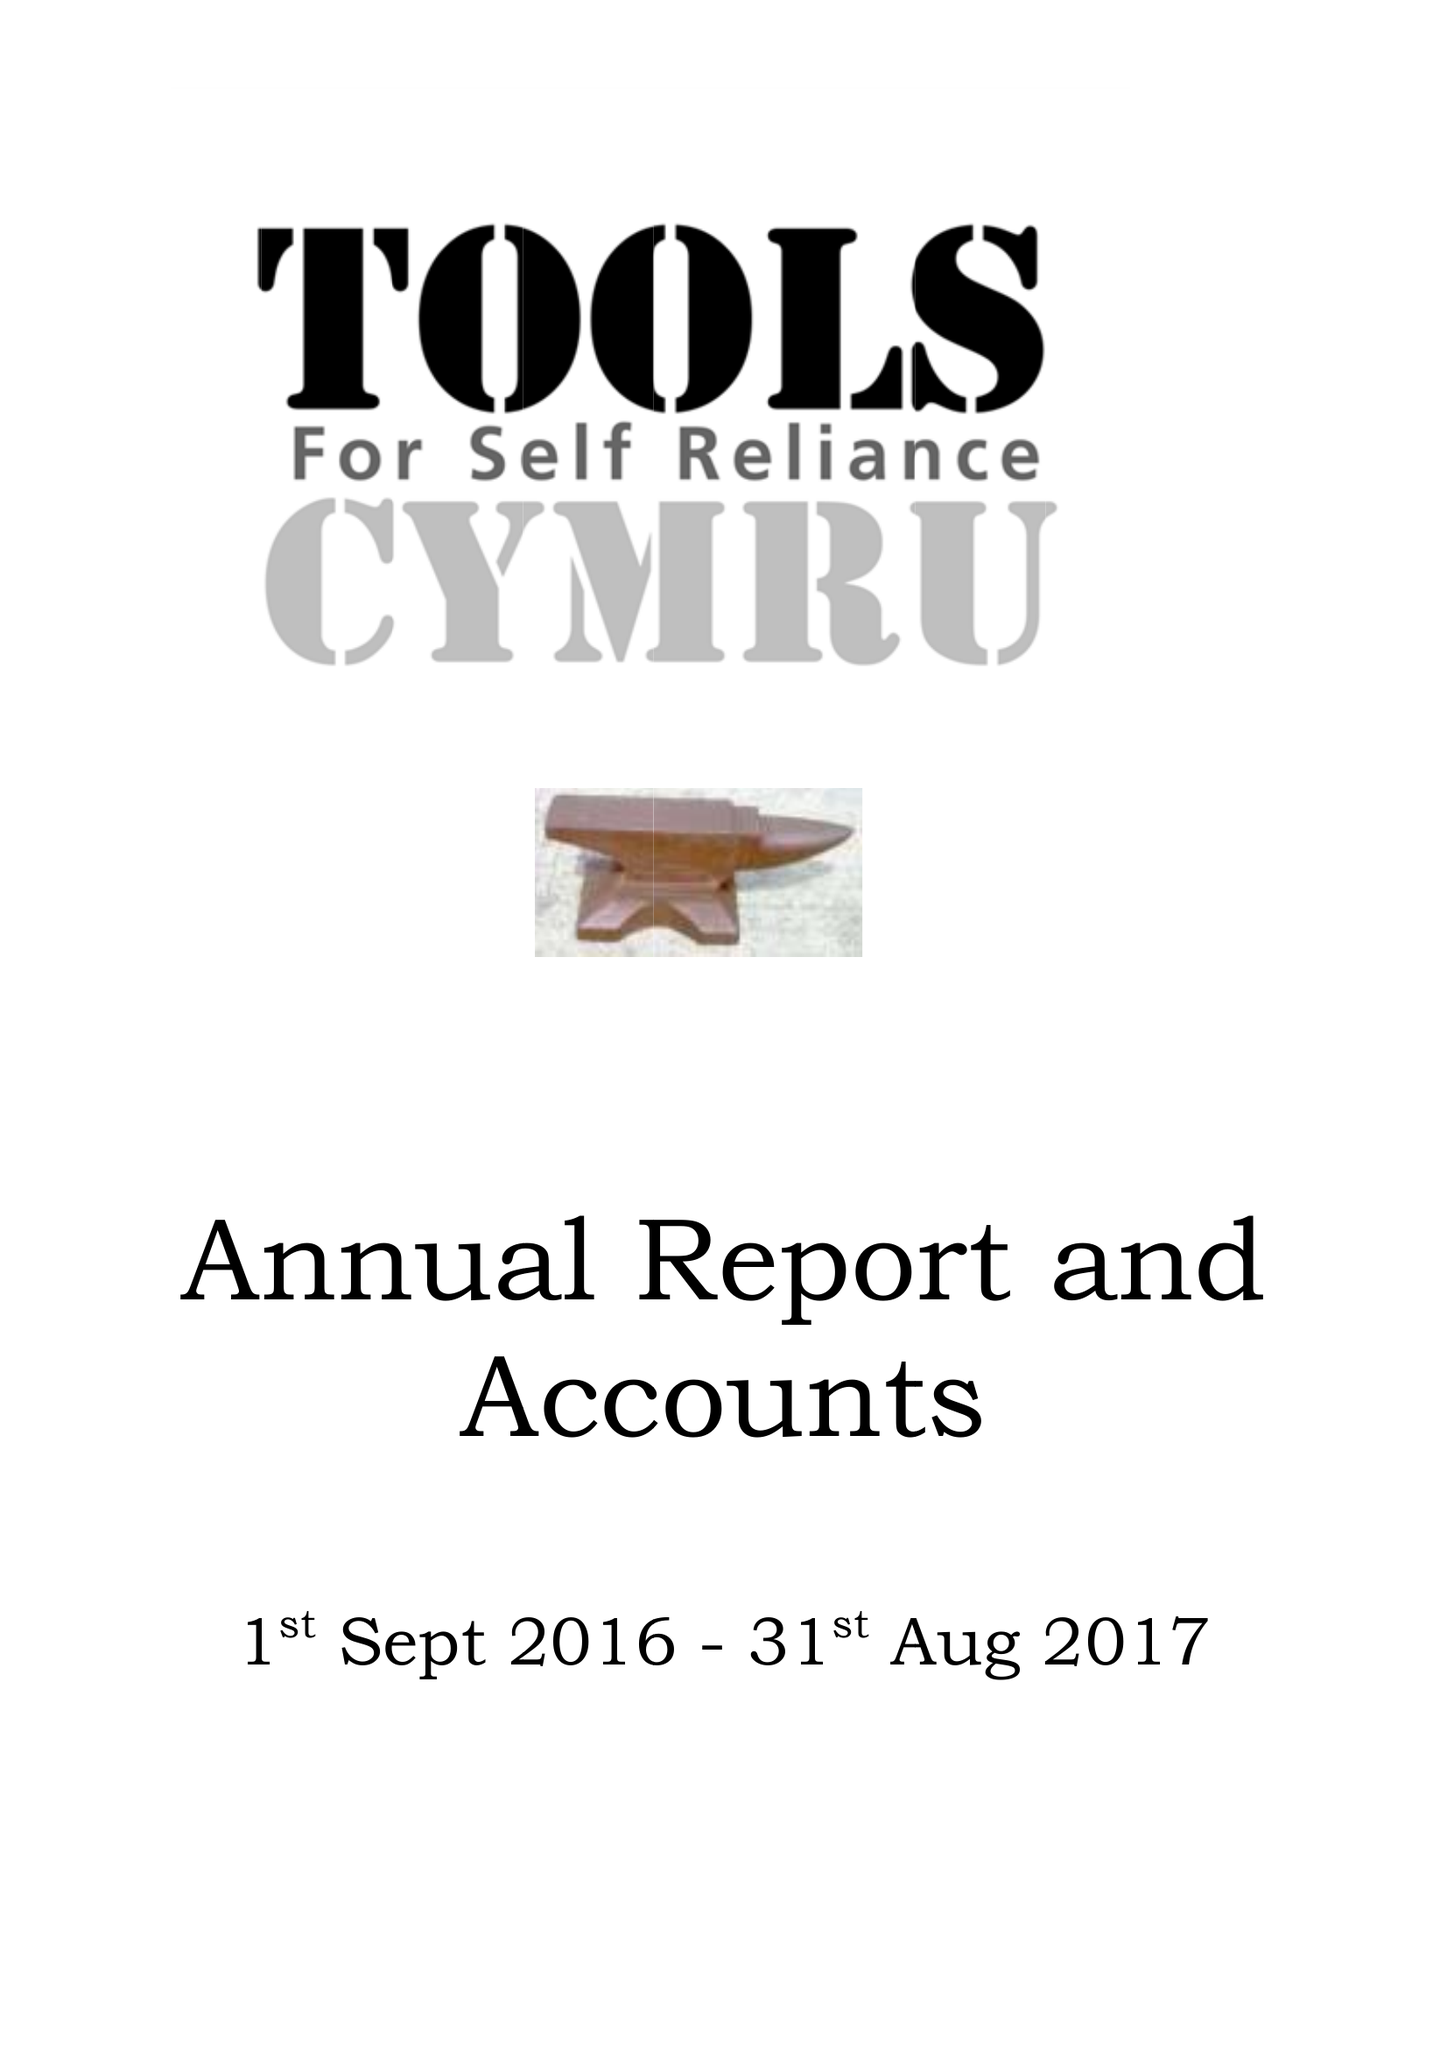What is the value for the address__street_line?
Answer the question using a single word or phrase. None 